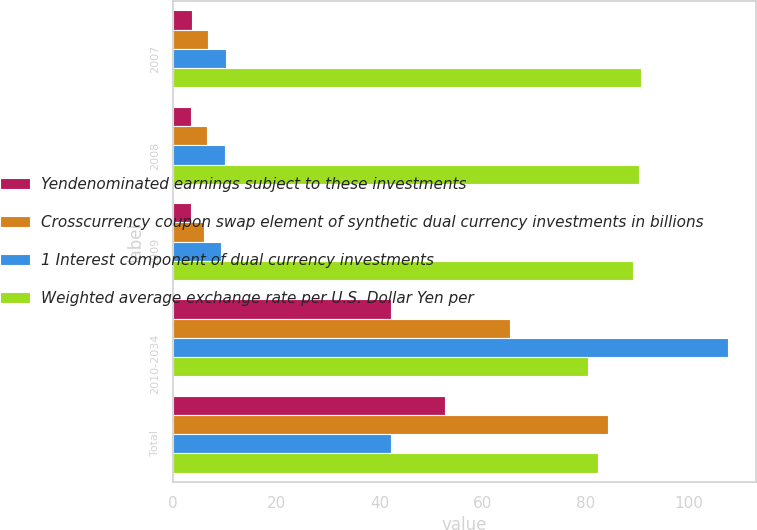<chart> <loc_0><loc_0><loc_500><loc_500><stacked_bar_chart><ecel><fcel>2007<fcel>2008<fcel>2009<fcel>2010-2034<fcel>Total<nl><fcel>Yendenominated earnings subject to these investments<fcel>3.6<fcel>3.5<fcel>3.4<fcel>42.3<fcel>52.8<nl><fcel>Crosscurrency coupon swap element of synthetic dual currency investments in billions<fcel>6.7<fcel>6.5<fcel>5.9<fcel>65.3<fcel>84.4<nl><fcel>1 Interest component of dual currency investments<fcel>10.3<fcel>10<fcel>9.3<fcel>107.6<fcel>42.3<nl><fcel>Weighted average exchange rate per U.S. Dollar Yen per<fcel>90.8<fcel>90.4<fcel>89.2<fcel>80.4<fcel>82.3<nl></chart> 